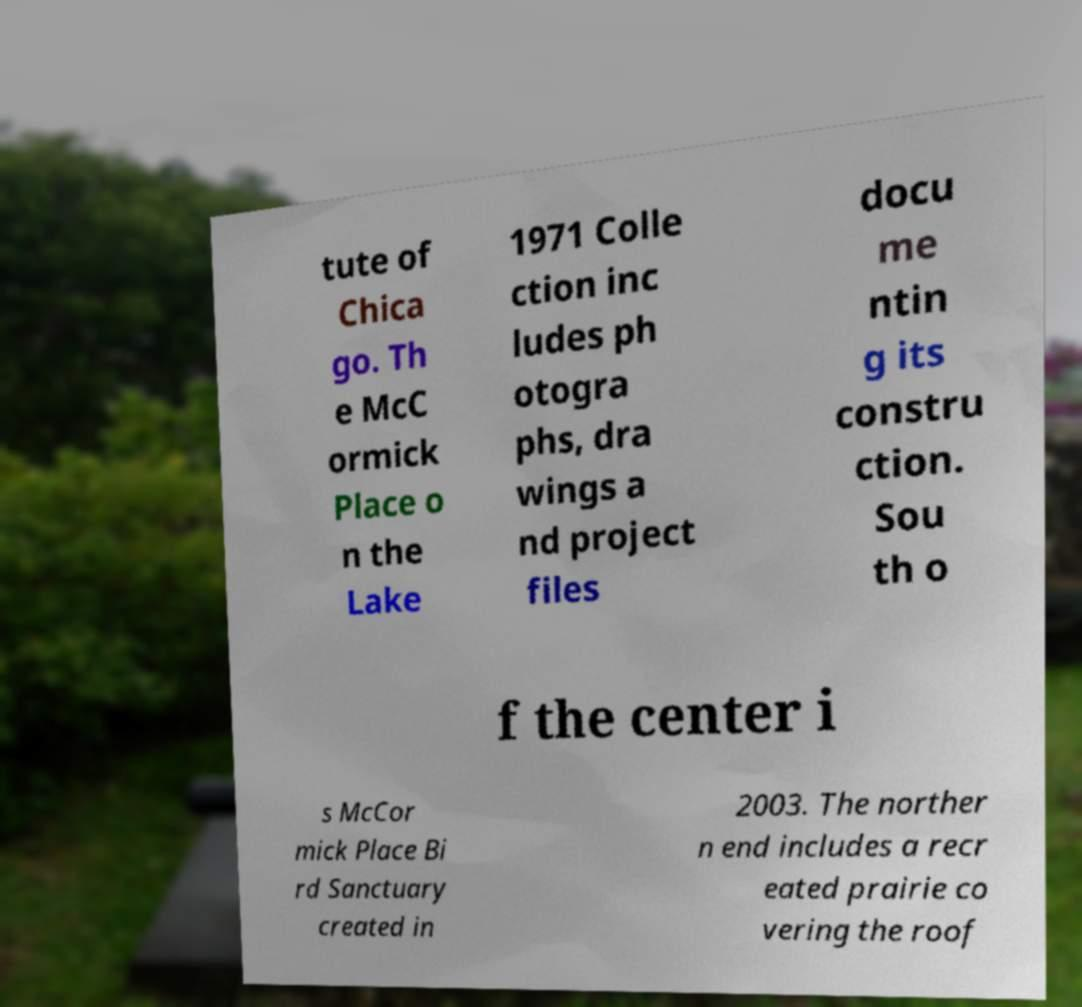Could you assist in decoding the text presented in this image and type it out clearly? tute of Chica go. Th e McC ormick Place o n the Lake 1971 Colle ction inc ludes ph otogra phs, dra wings a nd project files docu me ntin g its constru ction. Sou th o f the center i s McCor mick Place Bi rd Sanctuary created in 2003. The norther n end includes a recr eated prairie co vering the roof 